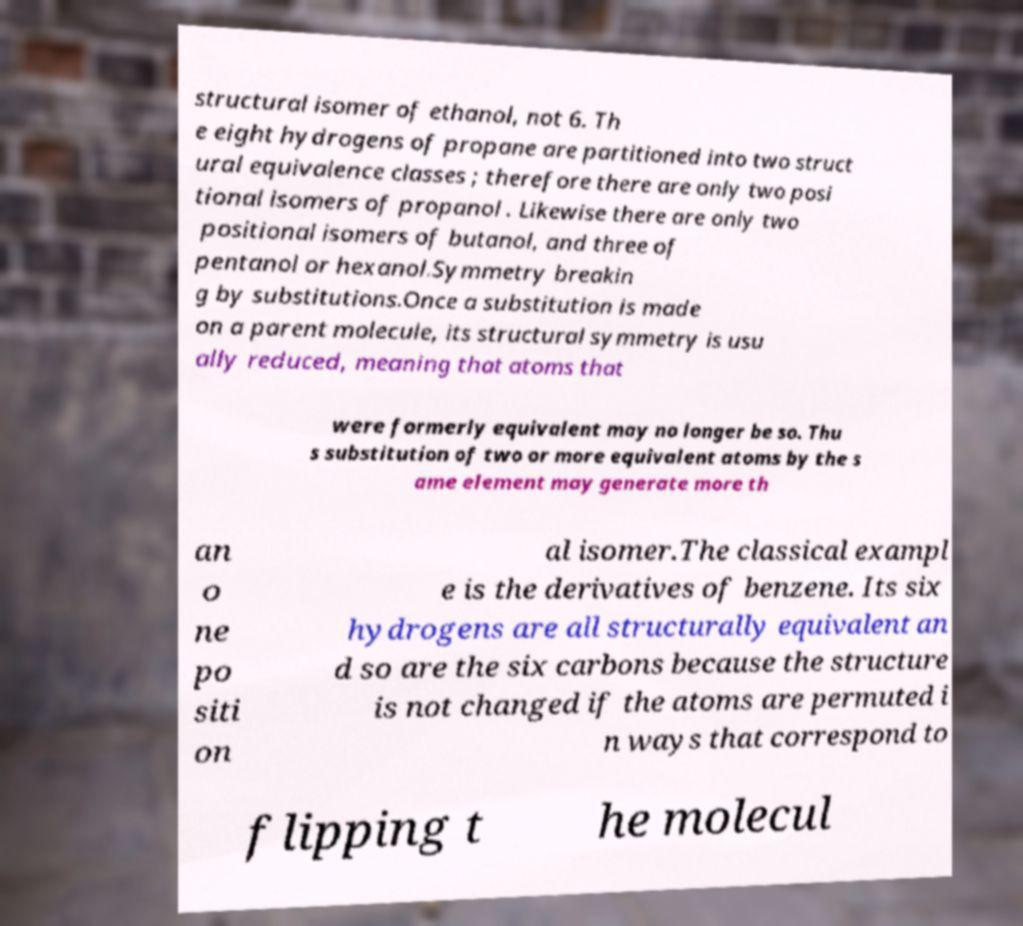Can you accurately transcribe the text from the provided image for me? structural isomer of ethanol, not 6. Th e eight hydrogens of propane are partitioned into two struct ural equivalence classes ; therefore there are only two posi tional isomers of propanol . Likewise there are only two positional isomers of butanol, and three of pentanol or hexanol.Symmetry breakin g by substitutions.Once a substitution is made on a parent molecule, its structural symmetry is usu ally reduced, meaning that atoms that were formerly equivalent may no longer be so. Thu s substitution of two or more equivalent atoms by the s ame element may generate more th an o ne po siti on al isomer.The classical exampl e is the derivatives of benzene. Its six hydrogens are all structurally equivalent an d so are the six carbons because the structure is not changed if the atoms are permuted i n ways that correspond to flipping t he molecul 